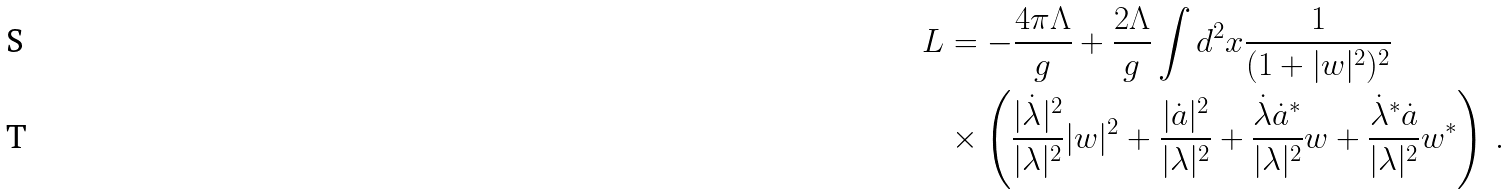Convert formula to latex. <formula><loc_0><loc_0><loc_500><loc_500>L & = - \frac { 4 \pi \Lambda } { g } + \frac { 2 \Lambda } { g } \int d ^ { 2 } x \frac { 1 } { ( 1 + | w | ^ { 2 } ) ^ { 2 } } \\ & \times \left ( \frac { | \dot { \lambda } | ^ { 2 } } { | \lambda | ^ { 2 } } | w | ^ { 2 } + \frac { | \dot { a } | ^ { 2 } } { | \lambda | ^ { 2 } } + \frac { \dot { \lambda } \dot { a } ^ { * } } { | \lambda | ^ { 2 } } w + \frac { \dot { \lambda } ^ { * } \dot { a } } { | \lambda | ^ { 2 } } w ^ { * } \right ) \, .</formula> 